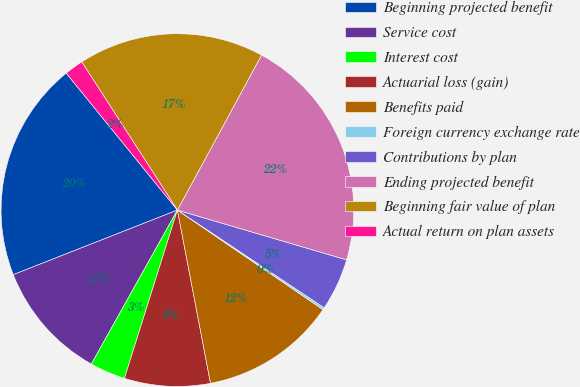Convert chart. <chart><loc_0><loc_0><loc_500><loc_500><pie_chart><fcel>Beginning projected benefit<fcel>Service cost<fcel>Interest cost<fcel>Actuarial loss (gain)<fcel>Benefits paid<fcel>Foreign currency exchange rate<fcel>Contributions by plan<fcel>Ending projected benefit<fcel>Beginning fair value of plan<fcel>Actual return on plan assets<nl><fcel>20.11%<fcel>10.92%<fcel>3.26%<fcel>7.86%<fcel>12.45%<fcel>0.2%<fcel>4.79%<fcel>21.64%<fcel>17.04%<fcel>1.73%<nl></chart> 